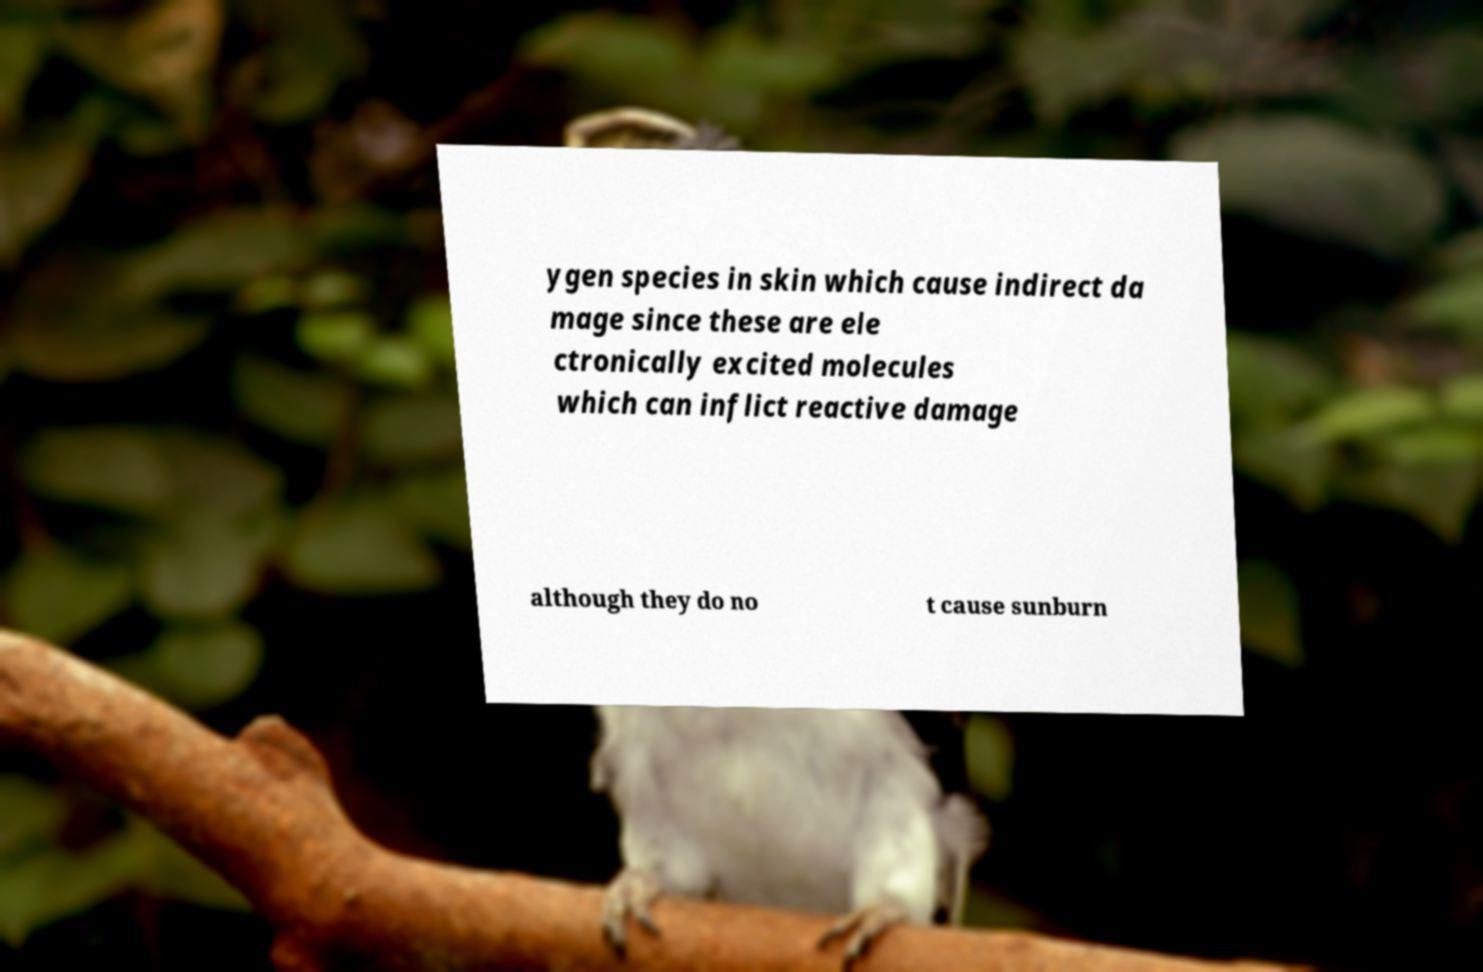Can you read and provide the text displayed in the image?This photo seems to have some interesting text. Can you extract and type it out for me? ygen species in skin which cause indirect da mage since these are ele ctronically excited molecules which can inflict reactive damage although they do no t cause sunburn 